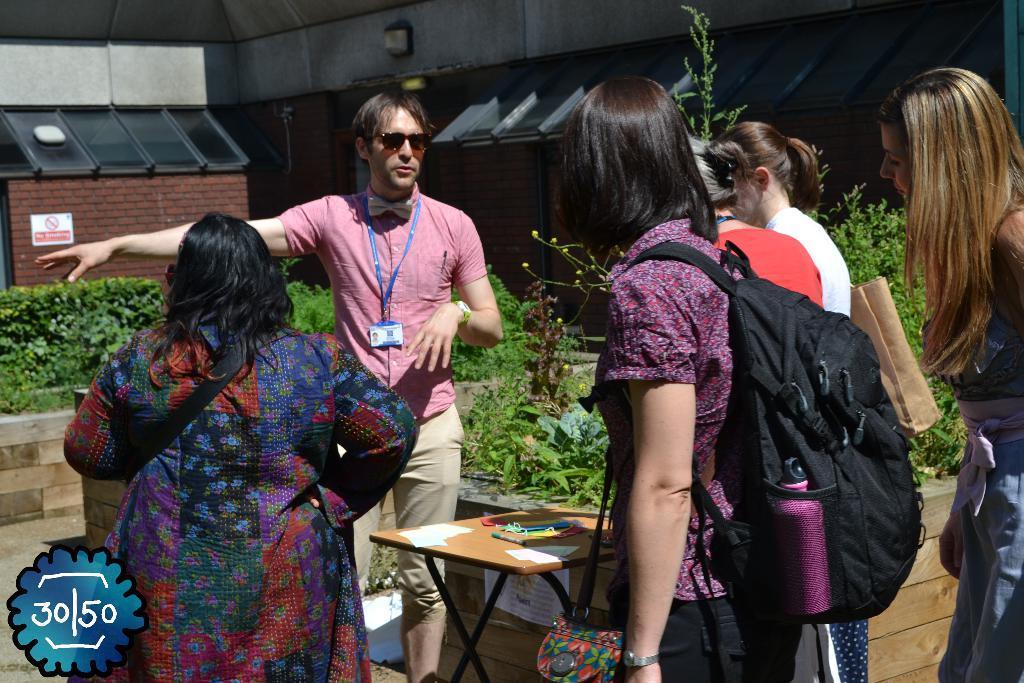Can you describe this image briefly? In the image we can see there are many people standing, they are wearing clothes, some of them are wearing goggles and carrying bags. Here we can see planets and a table. On the table we can see papers and other things. On the bottom left, we can see the watermark, here we can see wooden wall and it looks like the building. 